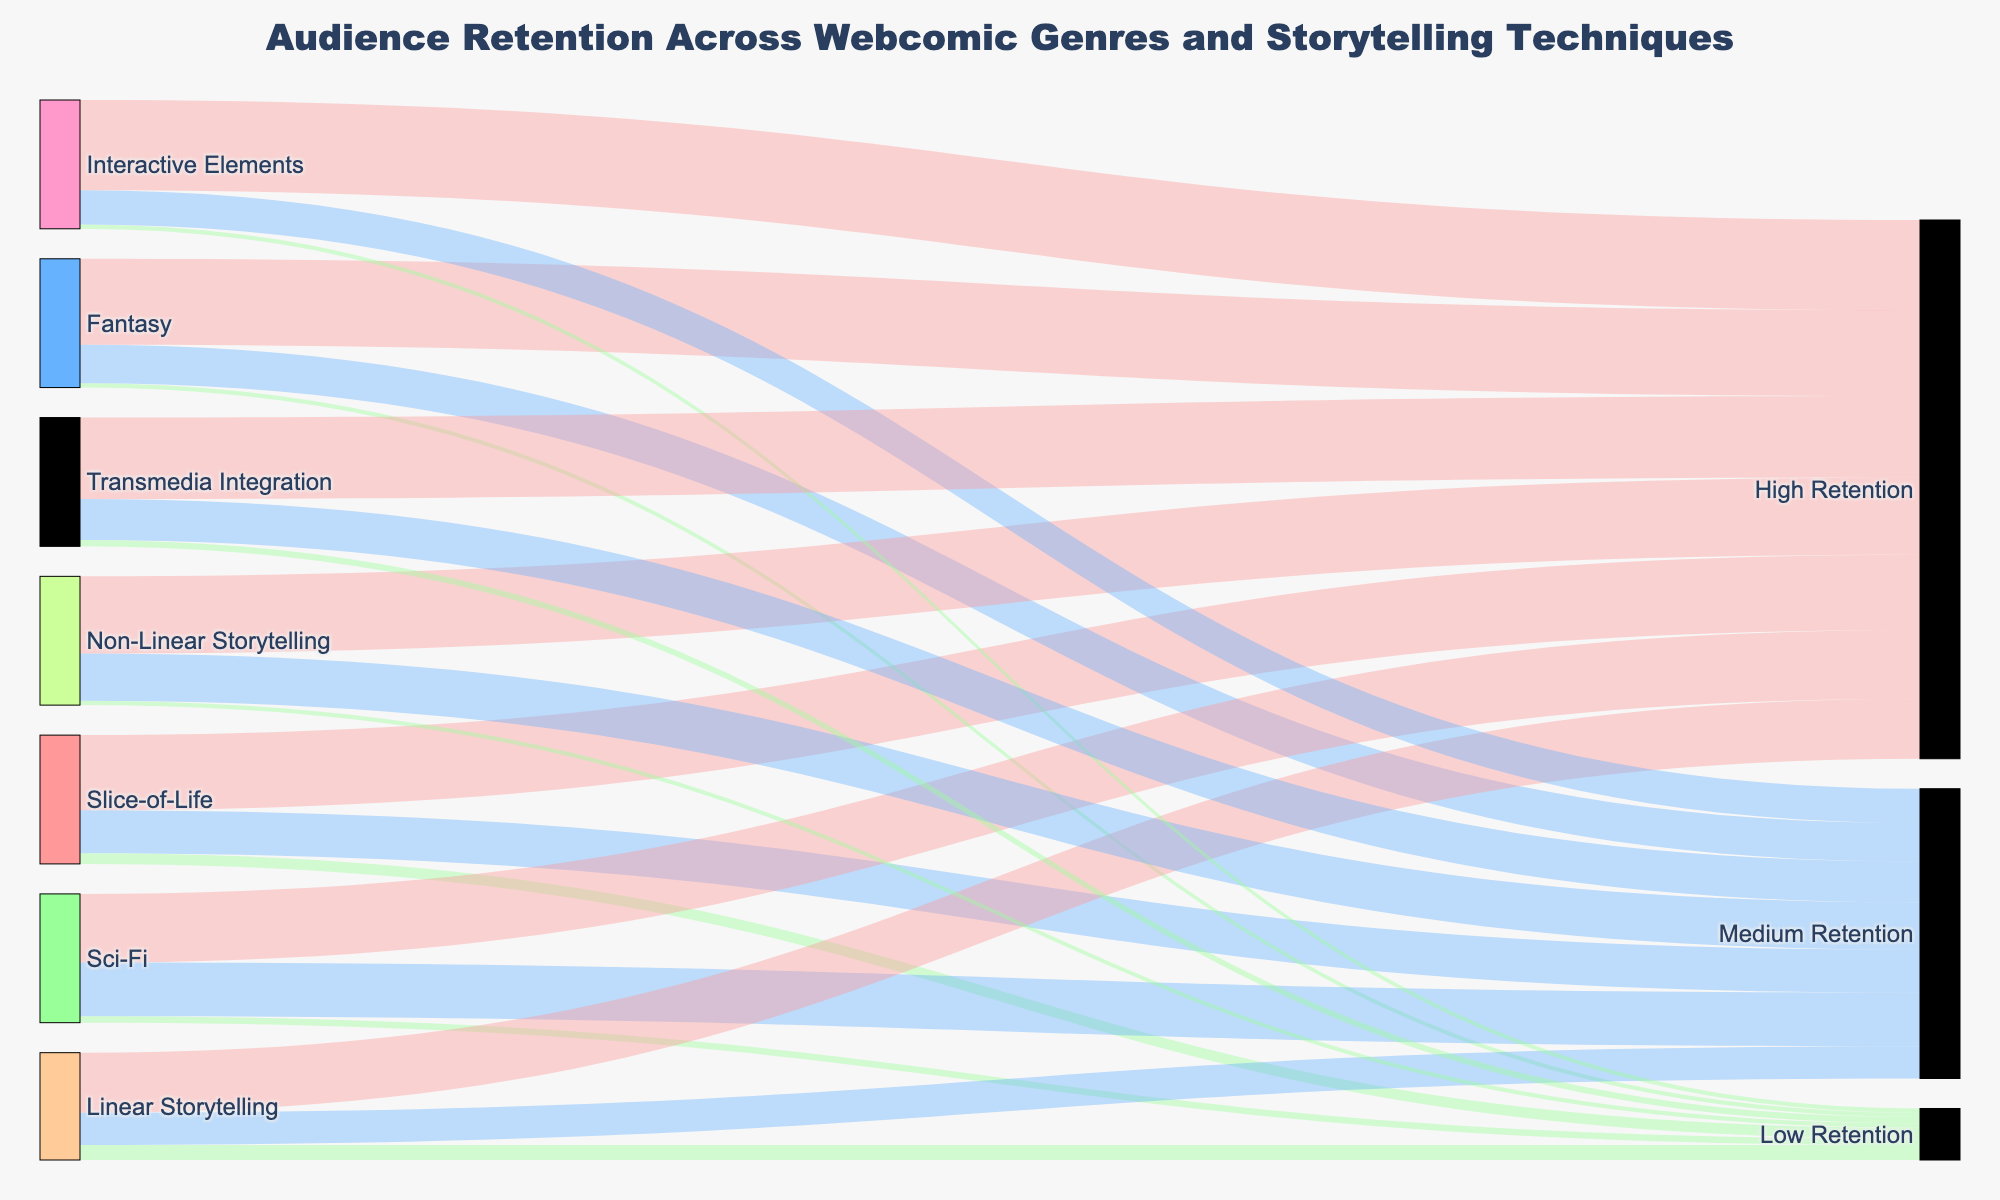What's the title of the diagram? The title of the diagram is typically located at the top and is meant to describe the main focus or content of the visual. From the provided information, the title is "Audience Retention Across Webcomic Genres and Storytelling Techniques."
Answer: Audience Retention Across Webcomic Genres and Storytelling Techniques How many different retention levels are shown in the diagram? The retention levels are displayed as part of the "Target" columns in the dataset. These levels are "High Retention," "Medium Retention," and "Low Retention."
Answer: 3 Which genre has the highest audience retention? By looking at the values under "High Retention" for each genre, we see that Fantasy has the highest value at 4000.
Answer: Fantasy What is the total audience retention for the Sci-Fi genre? To get the total audience retention for Sci-Fi, sum up the values across all retention levels for Sci-Fi: 3200 (High) + 2500 (Medium) + 300 (Low) = 6000.
Answer: 6000 Compare Linear Storytelling and Non-Linear Storytelling in terms of High Retention audience numbers. Which has a higher value and by how much? Non-Linear Storytelling has 3600 in High Retention, while Linear Storytelling has 2800. The difference is 3600 - 2800 = 800.
Answer: Non-Linear Storytelling, 800 What percentage of the audience for Interactive Elements falls under High Retention? For Interactive Elements, the High Retention count is 4200 and the total audience for Interactive Elements is 4200 (High) + 1600 (Medium) + 200 (Low) = 6000. The percentage is (4200 / 6000) * 100 = 70%.
Answer: 70% What is the combined audience value for "Medium Retention" across all storytelling techniques? Sum the Medium Retention audience values for each of the storytelling techniques: 1500 (Linear) + 2200 (Non-Linear) + 1600 (Interactive) + 1900 (Transmedia) = 7200.
Answer: 7200 Identify the storytelling technique with the highest number of Low Retention audience. By comparing the Low Retention values for each technique, Linear Storytelling has the highest number at 700.
Answer: Linear Storytelling What is the difference in audience between High Retention and Low Retention for the Slice-of-Life genre? The High Retention value for Slice-of-Life is 3500, and the Low Retention value is 500. The difference is 3500 - 500 = 3000.
Answer: 3000 Among all the genres and techniques, which has the lowest value for High Retention and what is that value? The values for High Retention are compared across all genres and techniques. The lowest is from the Linear Storytelling with a value of 2800.
Answer: Linear Storytelling, 2800 